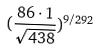<formula> <loc_0><loc_0><loc_500><loc_500>( \frac { 8 6 \cdot 1 } { \sqrt { 4 3 8 } } ) ^ { 9 / 2 9 2 }</formula> 